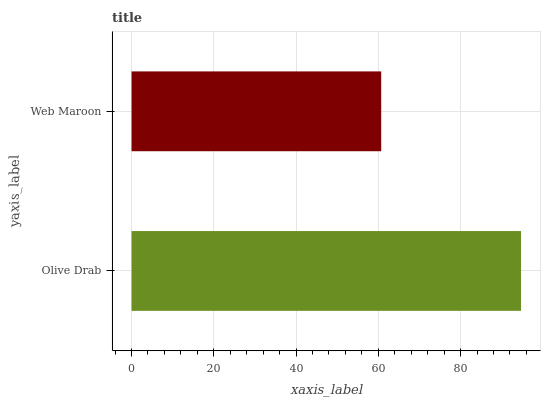Is Web Maroon the minimum?
Answer yes or no. Yes. Is Olive Drab the maximum?
Answer yes or no. Yes. Is Web Maroon the maximum?
Answer yes or no. No. Is Olive Drab greater than Web Maroon?
Answer yes or no. Yes. Is Web Maroon less than Olive Drab?
Answer yes or no. Yes. Is Web Maroon greater than Olive Drab?
Answer yes or no. No. Is Olive Drab less than Web Maroon?
Answer yes or no. No. Is Olive Drab the high median?
Answer yes or no. Yes. Is Web Maroon the low median?
Answer yes or no. Yes. Is Web Maroon the high median?
Answer yes or no. No. Is Olive Drab the low median?
Answer yes or no. No. 